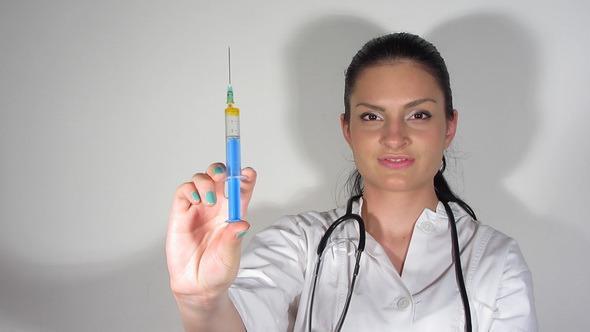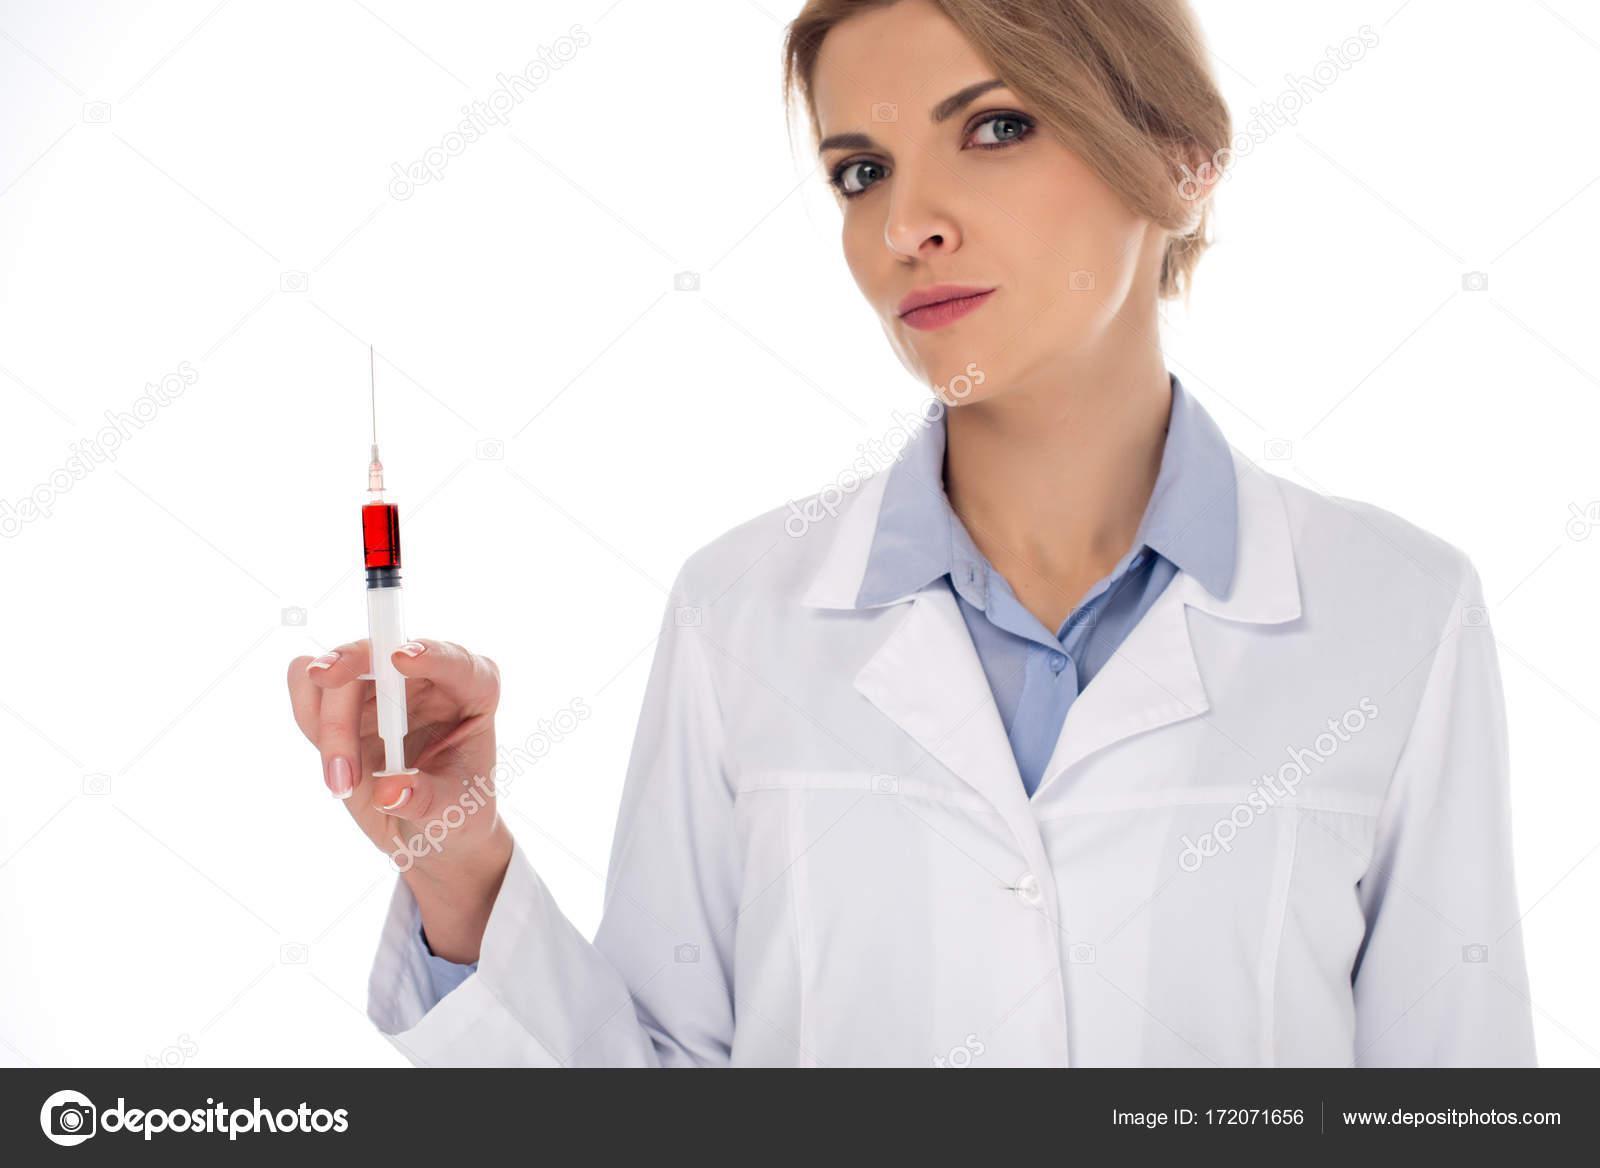The first image is the image on the left, the second image is the image on the right. Assess this claim about the two images: "Two women are holding syringes.". Correct or not? Answer yes or no. Yes. The first image is the image on the left, the second image is the image on the right. For the images displayed, is the sentence "There are two women holding needles." factually correct? Answer yes or no. Yes. 